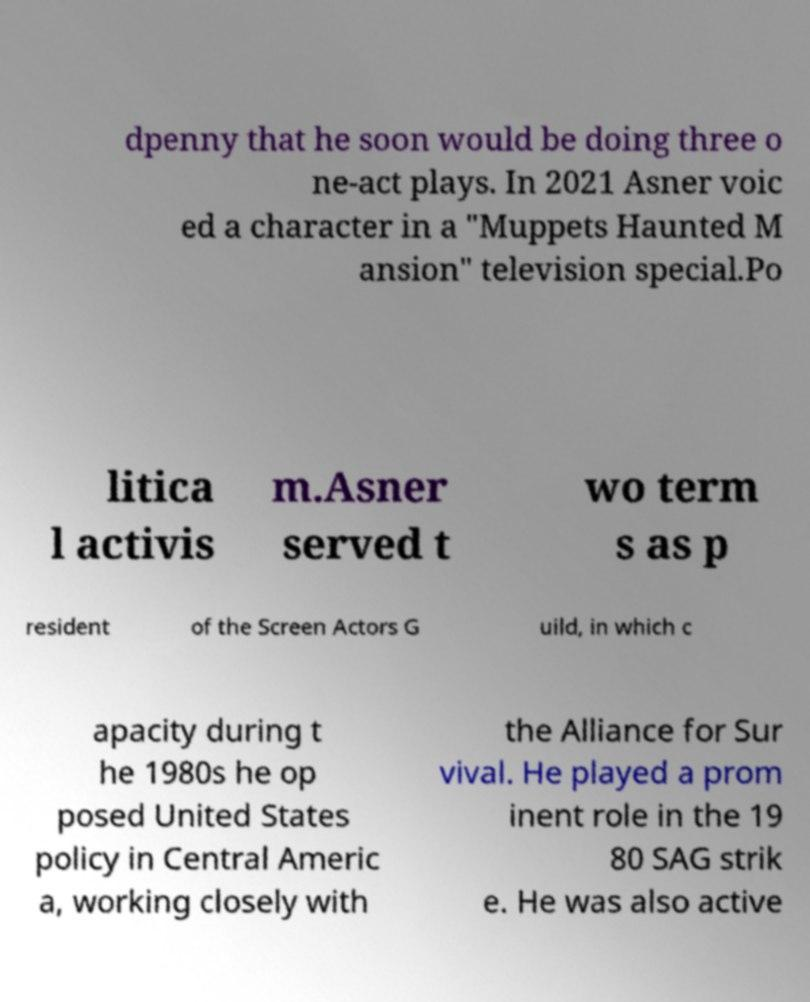For documentation purposes, I need the text within this image transcribed. Could you provide that? dpenny that he soon would be doing three o ne-act plays. In 2021 Asner voic ed a character in a "Muppets Haunted M ansion" television special.Po litica l activis m.Asner served t wo term s as p resident of the Screen Actors G uild, in which c apacity during t he 1980s he op posed United States policy in Central Americ a, working closely with the Alliance for Sur vival. He played a prom inent role in the 19 80 SAG strik e. He was also active 